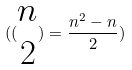<formula> <loc_0><loc_0><loc_500><loc_500>( ( \begin{matrix} n \\ 2 \end{matrix} ) = \frac { n ^ { 2 } - n } { 2 } )</formula> 